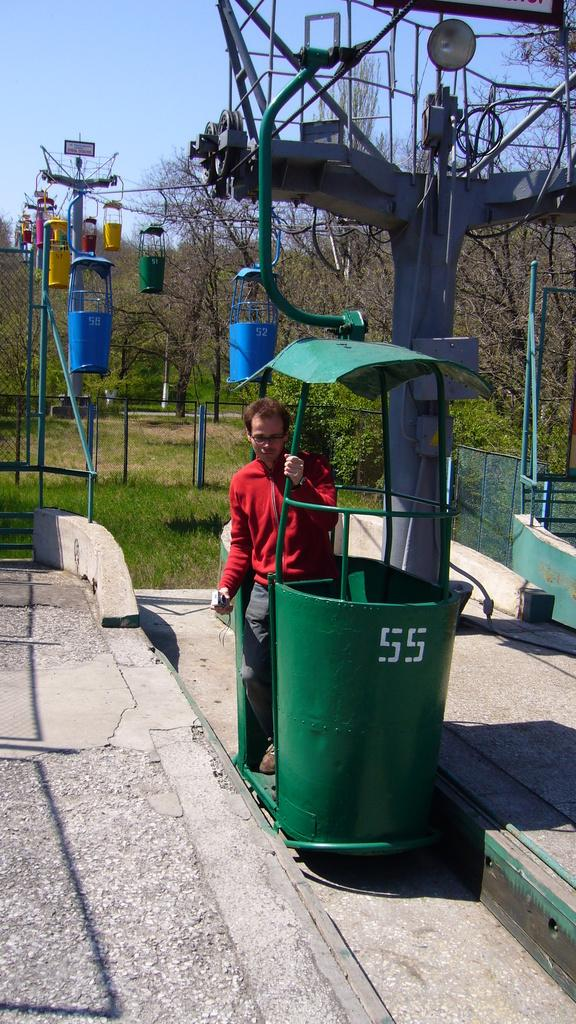<image>
Offer a succinct explanation of the picture presented. A man is in a green metal lift that has the number 55 on it. 